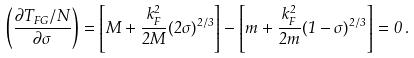Convert formula to latex. <formula><loc_0><loc_0><loc_500><loc_500>\left ( \frac { \partial T _ { F G } / N } { \partial \sigma } \right ) = \left [ M + \frac { k _ { F } ^ { 2 } } { 2 M } ( 2 \sigma ) ^ { 2 / 3 } \right ] - \left [ m + \frac { k _ { F } ^ { 2 } } { 2 m } ( 1 - \sigma ) ^ { 2 / 3 } \right ] = 0 \, .</formula> 